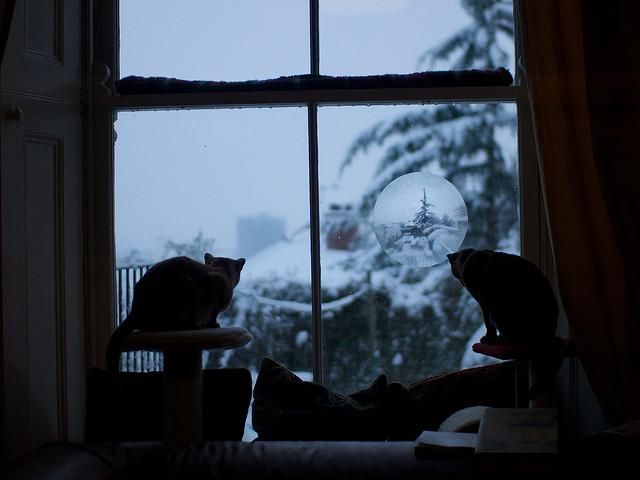Is it a sunny day?
Short answer required. No. Is the cat inside?
Quick response, please. Yes. What kind of bird is looking through the window?
Short answer required. None. How many cats?
Concise answer only. 2. What color is the couch?
Give a very brief answer. Black. What are the blurry birds doing?
Give a very brief answer. Sitting. Can you see through these curtains?
Concise answer only. Yes. Is the cat sleeping?
Short answer required. No. What animal is in the picture?
Write a very short answer. Cat. Are both of these cats real?
Answer briefly. Yes. Is it sunny outside?
Quick response, please. No. What type of animal is then picture?
Answer briefly. Cat. Is it raining?
Short answer required. No. What color chair is the cat sitting on?
Give a very brief answer. Black. What color is the window seal?
Quick response, please. Black. Is the weather cold?
Short answer required. Yes. What season is it?
Quick response, please. Winter. What happened to these animals?
Keep it brief. Nothing. Is it sunny?
Be succinct. No. How large is this animal?
Keep it brief. Small. What can be seen through the window?
Concise answer only. Snow. 